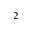Convert formula to latex. <formula><loc_0><loc_0><loc_500><loc_500>_ { 2 }</formula> 